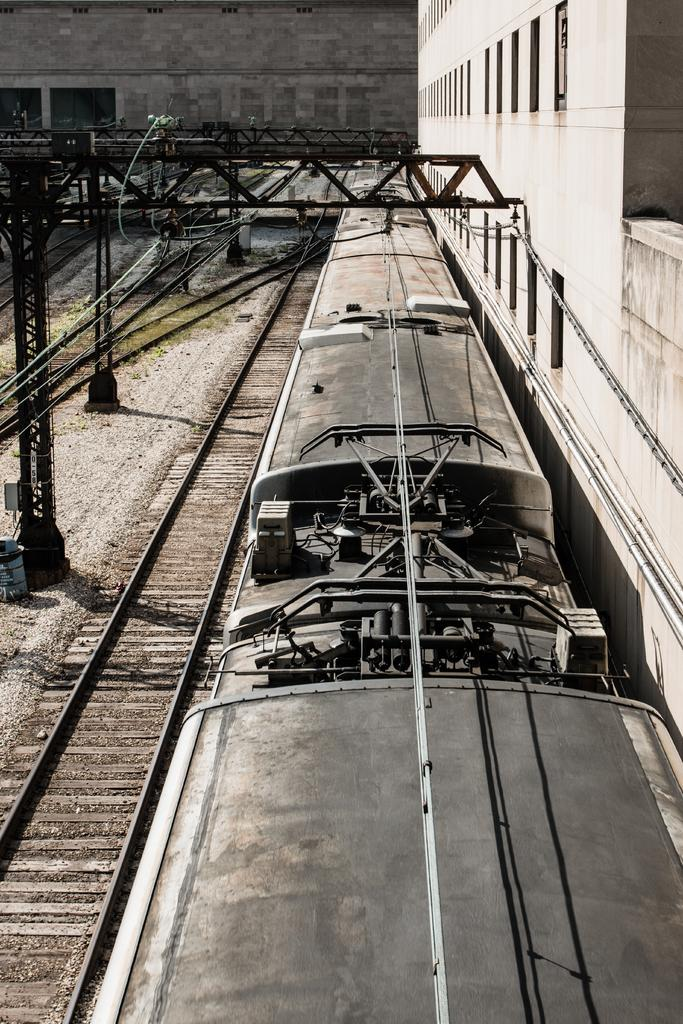What is the main subject of the image? The main subject of the image is a train. Where is the train located in the image? The train is on a track. What other structures can be seen in the image? There are pillars visible in the image. What is visible in the background of the image? There are buildings in the background of the image. Can you hear the train laughing in the image? There is no sound or indication of laughter in the image; it is a still image of a train on a track. 